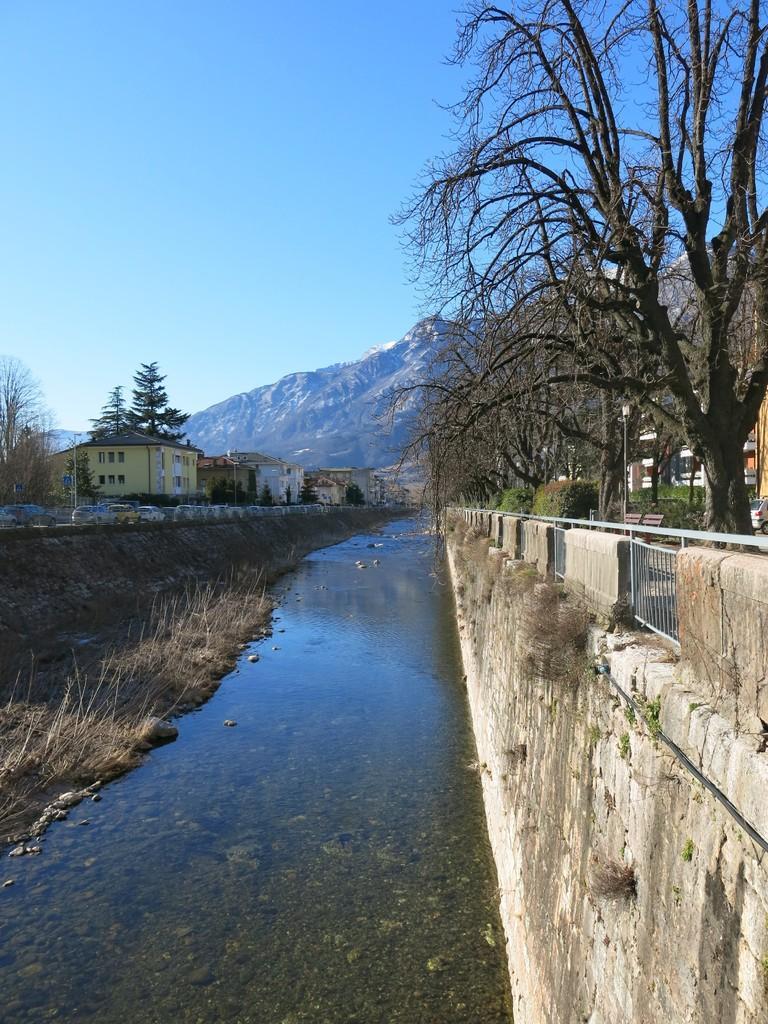In one or two sentences, can you explain what this image depicts? In this image there is a river in the bottom of this image and there are some trees on the right side of this image and left side of this image as well. there are houses in middle of this image and there is a hill in the background. There is a sky on the top of this image. 